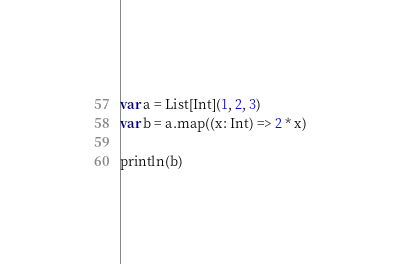<code> <loc_0><loc_0><loc_500><loc_500><_Scala_>var a = List[Int](1, 2, 3)
var b = a.map((x: Int) => 2 * x)

println(b)</code> 